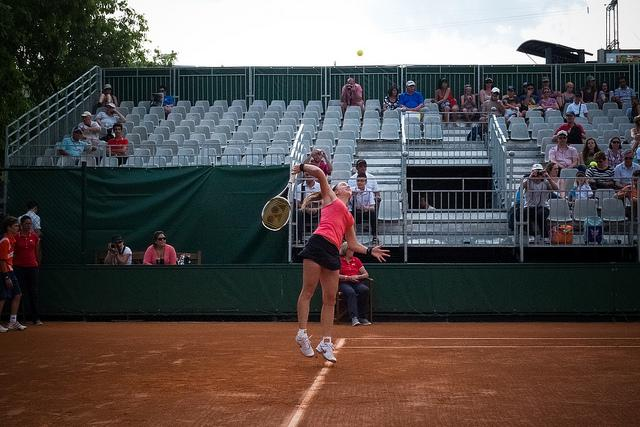What type of shot is the woman about to hit?

Choices:
A) serve
B) backhand
C) forehand
D) slice serve 